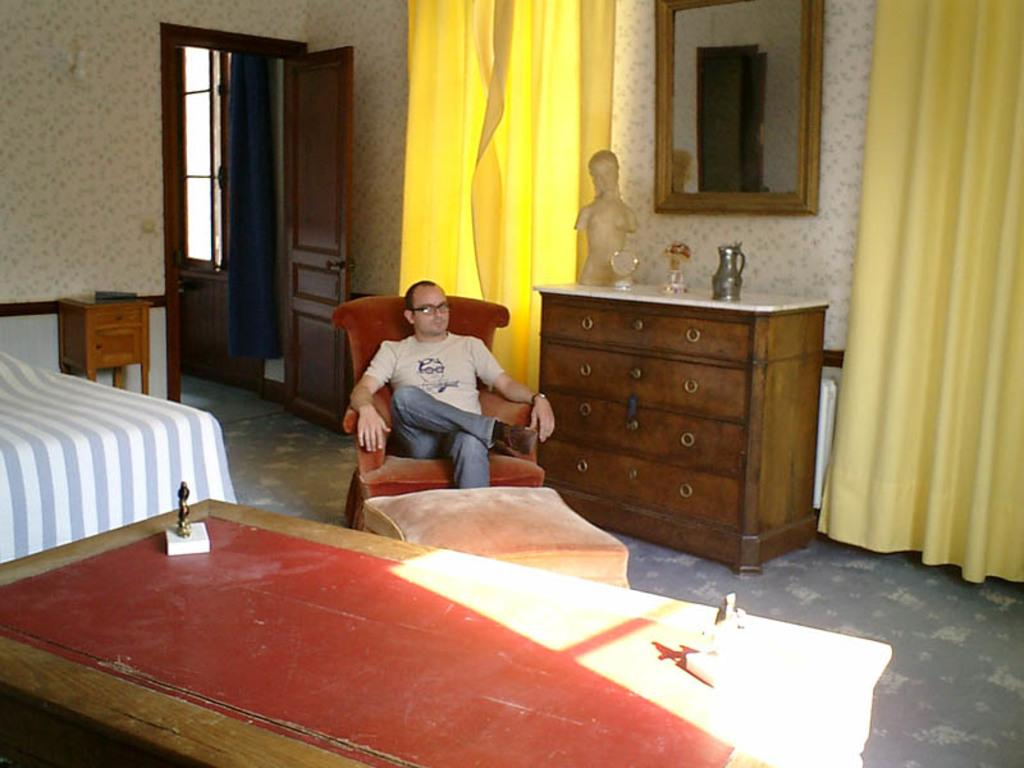Who is present in the image? There is a man in the image. What is the man doing in the image? The man is sitting on a chair. What other furniture can be seen in the image? There is a bed and a table in the image. What decorative items are on the table? There are two statues of a person on the table. What type of rainstorm is depicted in the image? There is no rainstorm present in the image. How does the mist affect the visibility in the image? There is no mist present in the image, so its effect on visibility cannot be determined. 